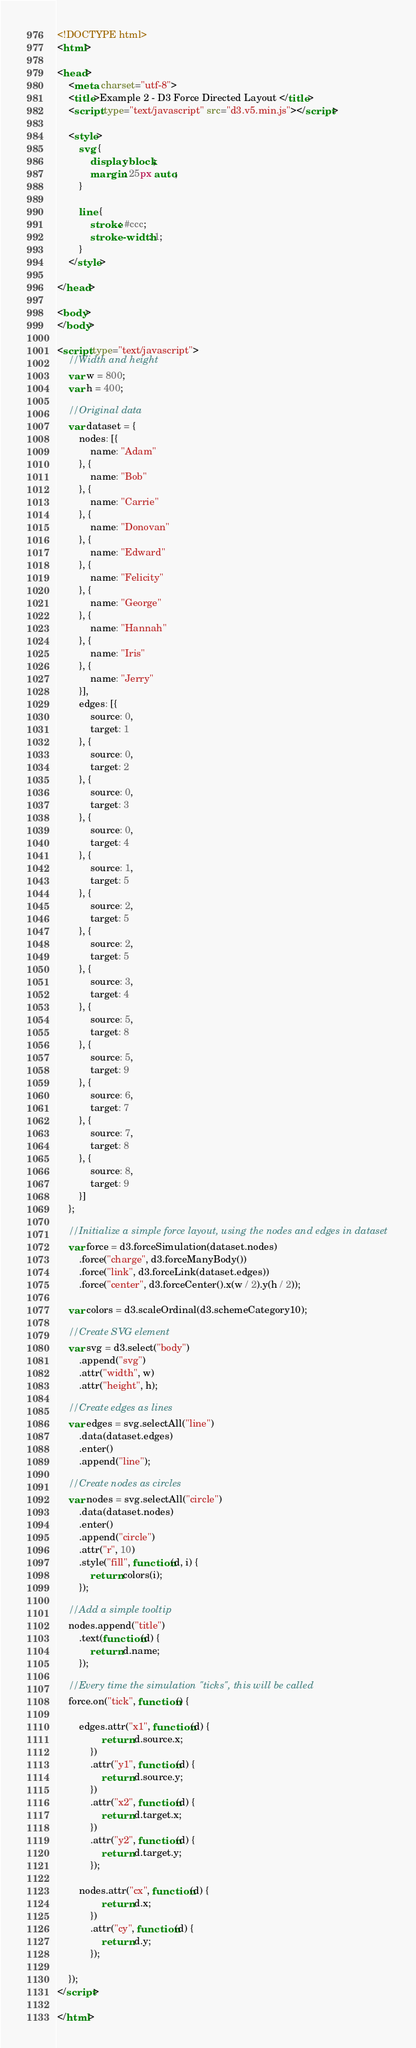Convert code to text. <code><loc_0><loc_0><loc_500><loc_500><_HTML_><!DOCTYPE html>
<html>

<head>
    <meta charset="utf-8">
    <title>Example 2 - D3 Force Directed Layout </title>
    <script type="text/javascript" src="d3.v5.min.js"></script>

    <style>
        svg {
            display: block;
            margin: 25px auto;
        }
        
        line {
            stroke: #ccc;
            stroke-width: 1;
        }
    </style>

</head>

<body>
</body>

<script type="text/javascript">
    //Width and height
    var w = 800;
    var h = 400;

    //Original data
    var dataset = {
        nodes: [{
            name: "Adam"
        }, {
            name: "Bob"
        }, {
            name: "Carrie"
        }, {
            name: "Donovan"
        }, {
            name: "Edward"
        }, {
            name: "Felicity"
        }, {
            name: "George"
        }, {
            name: "Hannah"
        }, {
            name: "Iris"
        }, {
            name: "Jerry"
        }],
        edges: [{
            source: 0,
            target: 1
        }, {
            source: 0,
            target: 2
        }, {
            source: 0,
            target: 3
        }, {
            source: 0,
            target: 4
        }, {
            source: 1,
            target: 5
        }, {
            source: 2,
            target: 5
        }, {
            source: 2,
            target: 5
        }, {
            source: 3,
            target: 4
        }, {
            source: 5,
            target: 8
        }, {
            source: 5,
            target: 9
        }, {
            source: 6,
            target: 7
        }, {
            source: 7,
            target: 8
        }, {
            source: 8,
            target: 9
        }]
    };

    //Initialize a simple force layout, using the nodes and edges in dataset
    var force = d3.forceSimulation(dataset.nodes)
        .force("charge", d3.forceManyBody())
        .force("link", d3.forceLink(dataset.edges))
        .force("center", d3.forceCenter().x(w / 2).y(h / 2));

    var colors = d3.scaleOrdinal(d3.schemeCategory10);

    //Create SVG element
    var svg = d3.select("body")
        .append("svg")
        .attr("width", w)
        .attr("height", h);

    //Create edges as lines
    var edges = svg.selectAll("line")
        .data(dataset.edges)
        .enter()
        .append("line");

    //Create nodes as circles
    var nodes = svg.selectAll("circle")
        .data(dataset.nodes)
        .enter()
        .append("circle")
        .attr("r", 10)
        .style("fill", function(d, i) {
            return colors(i);
        });

    //Add a simple tooltip
    nodes.append("title")
        .text(function(d) {
            return d.name;
        });

    //Every time the simulation "ticks", this will be called
    force.on("tick", function() {

        edges.attr("x1", function(d) {
                return d.source.x;
            })
            .attr("y1", function(d) {
                return d.source.y;
            })
            .attr("x2", function(d) {
                return d.target.x;
            })
            .attr("y2", function(d) {
                return d.target.y;
            });

        nodes.attr("cx", function(d) {
                return d.x;
            })
            .attr("cy", function(d) {
                return d.y;
            });

    });
</script>

</html></code> 